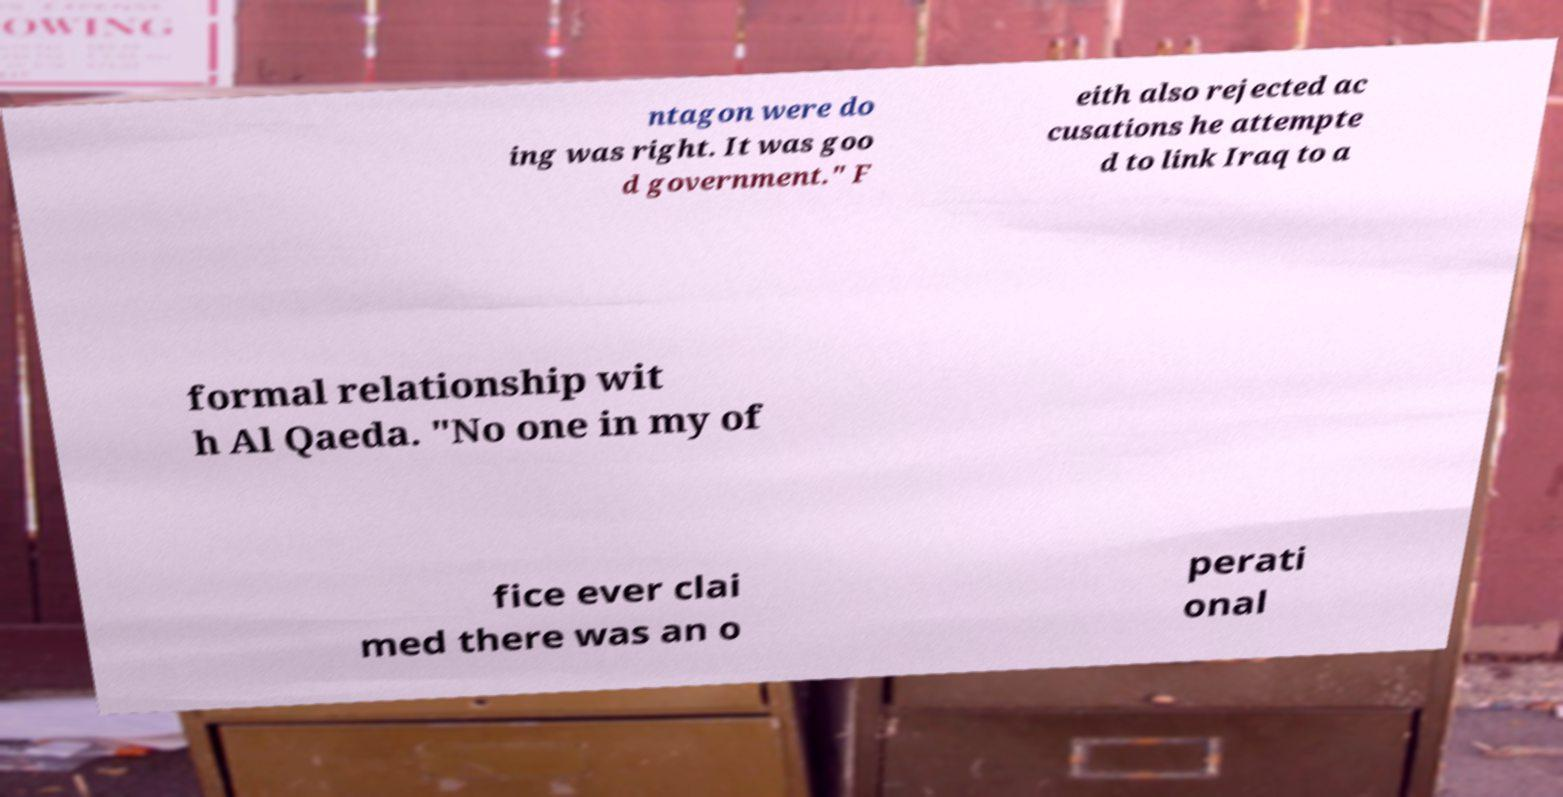Can you read and provide the text displayed in the image?This photo seems to have some interesting text. Can you extract and type it out for me? ntagon were do ing was right. It was goo d government." F eith also rejected ac cusations he attempte d to link Iraq to a formal relationship wit h Al Qaeda. "No one in my of fice ever clai med there was an o perati onal 